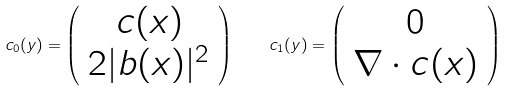<formula> <loc_0><loc_0><loc_500><loc_500>c _ { 0 } ( y ) = \left ( \begin{array} { c } c ( x ) \\ 2 | b ( x ) | ^ { 2 } \end{array} \right ) \quad c _ { 1 } ( y ) = \left ( \begin{array} { c } 0 \\ \nabla \cdot c ( x ) \end{array} \right )</formula> 